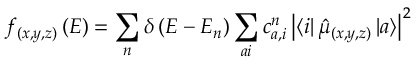<formula> <loc_0><loc_0><loc_500><loc_500>f _ { ( x , y , z ) } \left ( E \right ) = \sum _ { n } \delta \left ( E - E _ { n } \right ) \sum _ { a i } c _ { a , i } ^ { n } \left | \left \langle i \right | \hat { \mu } _ { ( x , y , z ) } \left | a \right \rangle \right | ^ { 2 }</formula> 